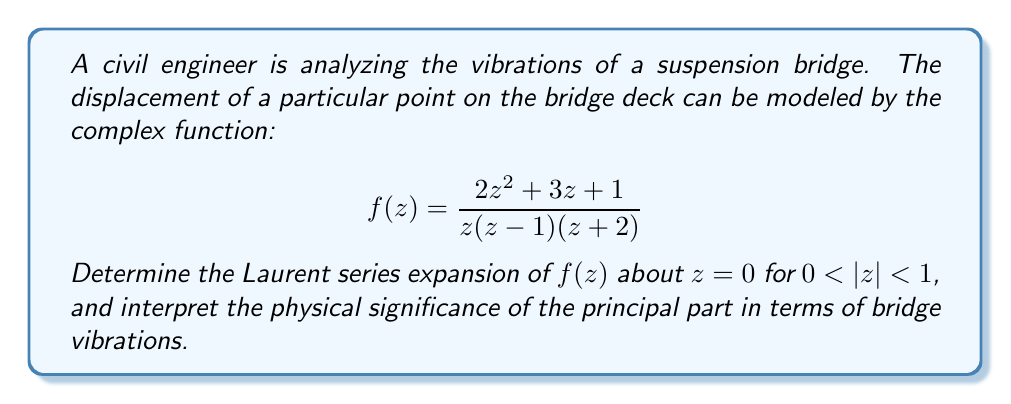Can you solve this math problem? To find the Laurent series expansion of $f(z)$ about $z=0$ for $0 < |z| < 1$, we need to follow these steps:

1) First, let's perform partial fraction decomposition on $f(z)$:

   $$f(z) = \frac{2z^2 + 3z + 1}{z(z-1)(z+2)} = \frac{A}{z} + \frac{B}{z-1} + \frac{C}{z+2}$$

2) Solving for A, B, and C:

   $$A = \lim_{z \to 0} zf(z) = \lim_{z \to 0} \frac{2z^2 + 3z + 1}{(z-1)(z+2)} = -\frac{1}{2}$$
   
   $$B = \lim_{z \to 1} (z-1)f(z) = \lim_{z \to 1} \frac{2z^2 + 3z + 1}{z(z+2)} = \frac{6}{3} = 2$$
   
   $$C = \lim_{z \to -2} (z+2)f(z) = \lim_{z \to -2} \frac{2z^2 + 3z + 1}{z(z-1)} = -\frac{3}{2}$$

3) Therefore, we can write:

   $$f(z) = -\frac{1}{2z} + \frac{2}{z-1} - \frac{3/2}{z+2}$$

4) Now, we need to expand each term for $0 < |z| < 1$:

   $$-\frac{1}{2z} \text{ is already in the correct form}$$
   
   $$\frac{2}{z-1} = -2(1-z)^{-1} = -2(1+z+z^2+z^3+...)$$
   
   $$-\frac{3/2}{z+2} = -\frac{3/2}{2(1+z/2)} = -\frac{3}{4}(1-\frac{z}{2}+\frac{z^2}{4}-\frac{z^3}{8}+...)$$

5) Combining these terms:

   $$f(z) = -\frac{1}{2z} - 2 - 2z - 2z^2 - 2z^3 - ... - \frac{3}{4} + \frac{3}{8}z - \frac{3}{16}z^2 + \frac{3}{32}z^3 - ...$$

6) Rearranging terms:

   $$f(z) = -\frac{1}{2z} + (-\frac{11}{4}) + (-\frac{13}{8})z + (-\frac{35}{16})z^2 + (-\frac{61}{32})z^3 + ...$$

This is the Laurent series expansion of $f(z)$ about $z=0$ for $0 < |z| < 1$.

The physical significance of the principal part $(-\frac{1}{2z})$ in terms of bridge vibrations:

The term $-\frac{1}{2z}$ represents a singularity at $z=0$, which could be interpreted as a point of infinite displacement. In the context of bridge vibrations, this might represent a critical point where the vibration amplitude becomes extremely large, potentially leading to resonance or structural failure if not properly managed. The negative sign suggests that this displacement is in the opposite direction of the positive z-axis.

The presence of this term in the Laurent series indicates that the engineer should pay special attention to the behavior of the bridge near this point, as it could be a location of significant stress or potential instability in the structure.
Answer: The Laurent series expansion of $f(z)$ about $z=0$ for $0 < |z| < 1$ is:

$$f(z) = -\frac{1}{2z} + (-\frac{11}{4}) + (-\frac{13}{8})z + (-\frac{35}{16})z^2 + (-\frac{61}{32})z^3 + ...$$

The principal part $(-\frac{1}{2z})$ represents a point of potential infinite displacement, indicating a critical area for structural analysis in the bridge. 